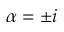Convert formula to latex. <formula><loc_0><loc_0><loc_500><loc_500>\alpha = \pm i</formula> 